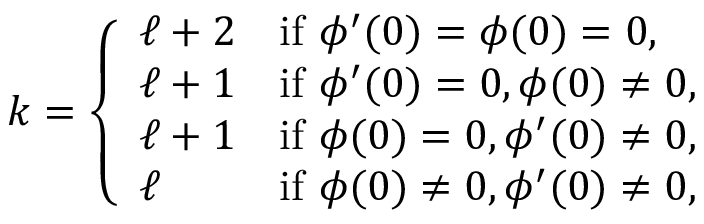Convert formula to latex. <formula><loc_0><loc_0><loc_500><loc_500>k = \left \{ \begin{array} { l l } { \ell + 2 } & { i f \phi ^ { \prime } ( 0 ) = \phi ( 0 ) = 0 , } \\ { \ell + 1 } & { i f \phi ^ { \prime } ( 0 ) = 0 , \phi ( 0 ) \neq 0 , } \\ { \ell + 1 } & { i f \phi ( 0 ) = 0 , \phi ^ { \prime } ( 0 ) \neq 0 , } \\ { \ell } & { i f \phi ( 0 ) \neq 0 , \phi ^ { \prime } ( 0 ) \neq 0 , } \end{array}</formula> 